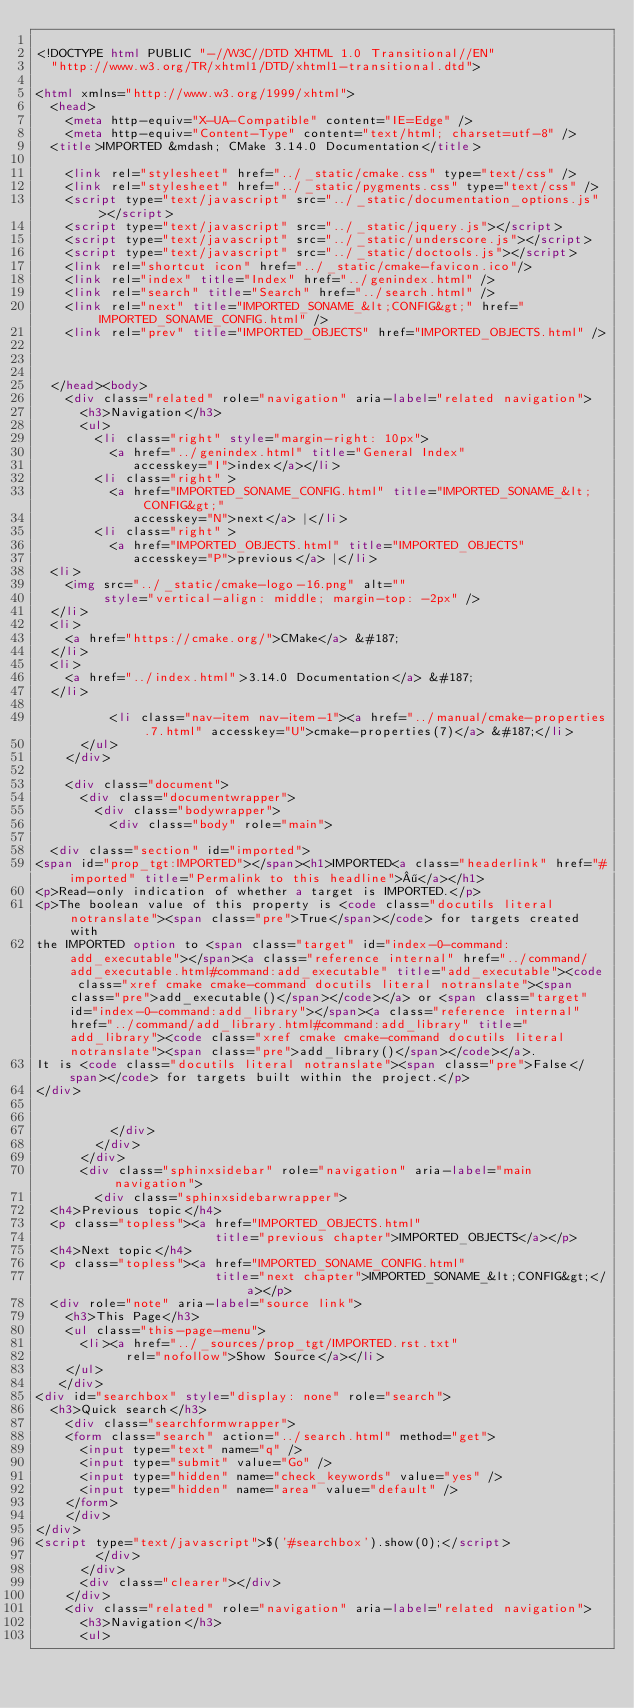Convert code to text. <code><loc_0><loc_0><loc_500><loc_500><_HTML_>
<!DOCTYPE html PUBLIC "-//W3C//DTD XHTML 1.0 Transitional//EN"
  "http://www.w3.org/TR/xhtml1/DTD/xhtml1-transitional.dtd">

<html xmlns="http://www.w3.org/1999/xhtml">
  <head>
    <meta http-equiv="X-UA-Compatible" content="IE=Edge" />
    <meta http-equiv="Content-Type" content="text/html; charset=utf-8" />
  <title>IMPORTED &mdash; CMake 3.14.0 Documentation</title>

    <link rel="stylesheet" href="../_static/cmake.css" type="text/css" />
    <link rel="stylesheet" href="../_static/pygments.css" type="text/css" />
    <script type="text/javascript" src="../_static/documentation_options.js"></script>
    <script type="text/javascript" src="../_static/jquery.js"></script>
    <script type="text/javascript" src="../_static/underscore.js"></script>
    <script type="text/javascript" src="../_static/doctools.js"></script>
    <link rel="shortcut icon" href="../_static/cmake-favicon.ico"/>
    <link rel="index" title="Index" href="../genindex.html" />
    <link rel="search" title="Search" href="../search.html" />
    <link rel="next" title="IMPORTED_SONAME_&lt;CONFIG&gt;" href="IMPORTED_SONAME_CONFIG.html" />
    <link rel="prev" title="IMPORTED_OBJECTS" href="IMPORTED_OBJECTS.html" />
  
 

  </head><body>
    <div class="related" role="navigation" aria-label="related navigation">
      <h3>Navigation</h3>
      <ul>
        <li class="right" style="margin-right: 10px">
          <a href="../genindex.html" title="General Index"
             accesskey="I">index</a></li>
        <li class="right" >
          <a href="IMPORTED_SONAME_CONFIG.html" title="IMPORTED_SONAME_&lt;CONFIG&gt;"
             accesskey="N">next</a> |</li>
        <li class="right" >
          <a href="IMPORTED_OBJECTS.html" title="IMPORTED_OBJECTS"
             accesskey="P">previous</a> |</li>
  <li>
    <img src="../_static/cmake-logo-16.png" alt=""
         style="vertical-align: middle; margin-top: -2px" />
  </li>
  <li>
    <a href="https://cmake.org/">CMake</a> &#187;
  </li>
  <li>
    <a href="../index.html">3.14.0 Documentation</a> &#187;
  </li>

          <li class="nav-item nav-item-1"><a href="../manual/cmake-properties.7.html" accesskey="U">cmake-properties(7)</a> &#187;</li> 
      </ul>
    </div>  

    <div class="document">
      <div class="documentwrapper">
        <div class="bodywrapper">
          <div class="body" role="main">
            
  <div class="section" id="imported">
<span id="prop_tgt:IMPORTED"></span><h1>IMPORTED<a class="headerlink" href="#imported" title="Permalink to this headline">¶</a></h1>
<p>Read-only indication of whether a target is IMPORTED.</p>
<p>The boolean value of this property is <code class="docutils literal notranslate"><span class="pre">True</span></code> for targets created with
the IMPORTED option to <span class="target" id="index-0-command:add_executable"></span><a class="reference internal" href="../command/add_executable.html#command:add_executable" title="add_executable"><code class="xref cmake cmake-command docutils literal notranslate"><span class="pre">add_executable()</span></code></a> or <span class="target" id="index-0-command:add_library"></span><a class="reference internal" href="../command/add_library.html#command:add_library" title="add_library"><code class="xref cmake cmake-command docutils literal notranslate"><span class="pre">add_library()</span></code></a>.
It is <code class="docutils literal notranslate"><span class="pre">False</span></code> for targets built within the project.</p>
</div>


          </div>
        </div>
      </div>
      <div class="sphinxsidebar" role="navigation" aria-label="main navigation">
        <div class="sphinxsidebarwrapper">
  <h4>Previous topic</h4>
  <p class="topless"><a href="IMPORTED_OBJECTS.html"
                        title="previous chapter">IMPORTED_OBJECTS</a></p>
  <h4>Next topic</h4>
  <p class="topless"><a href="IMPORTED_SONAME_CONFIG.html"
                        title="next chapter">IMPORTED_SONAME_&lt;CONFIG&gt;</a></p>
  <div role="note" aria-label="source link">
    <h3>This Page</h3>
    <ul class="this-page-menu">
      <li><a href="../_sources/prop_tgt/IMPORTED.rst.txt"
            rel="nofollow">Show Source</a></li>
    </ul>
   </div>
<div id="searchbox" style="display: none" role="search">
  <h3>Quick search</h3>
    <div class="searchformwrapper">
    <form class="search" action="../search.html" method="get">
      <input type="text" name="q" />
      <input type="submit" value="Go" />
      <input type="hidden" name="check_keywords" value="yes" />
      <input type="hidden" name="area" value="default" />
    </form>
    </div>
</div>
<script type="text/javascript">$('#searchbox').show(0);</script>
        </div>
      </div>
      <div class="clearer"></div>
    </div>
    <div class="related" role="navigation" aria-label="related navigation">
      <h3>Navigation</h3>
      <ul></code> 